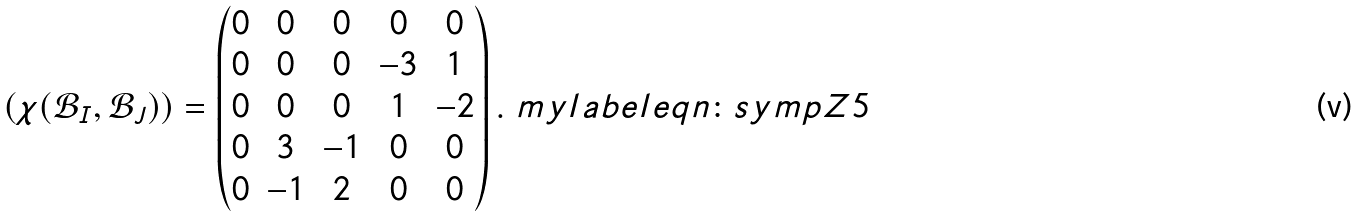Convert formula to latex. <formula><loc_0><loc_0><loc_500><loc_500>( \chi ( \mathcal { B } _ { I } , \mathcal { B } _ { J } ) ) = \left ( \begin{matrix} 0 & 0 & 0 & 0 & 0 \\ 0 & 0 & 0 & - 3 & 1 \\ 0 & 0 & 0 & 1 & - 2 \\ 0 & 3 & - 1 & 0 & 0 \\ 0 & - 1 & 2 & 0 & 0 \\ \end{matrix} \right ) . \ m y l a b e l { e q n \colon s y m p Z 5 }</formula> 